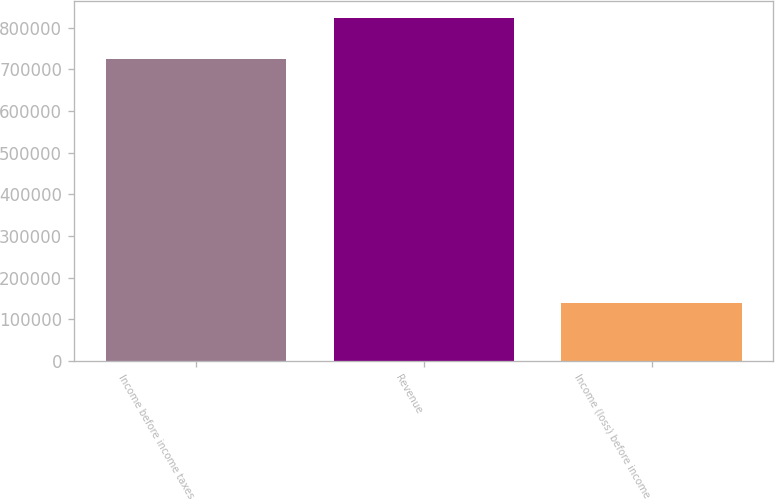<chart> <loc_0><loc_0><loc_500><loc_500><bar_chart><fcel>Income before income taxes<fcel>Revenue<fcel>Income (loss) before income<nl><fcel>724667<fcel>823663<fcel>139415<nl></chart> 